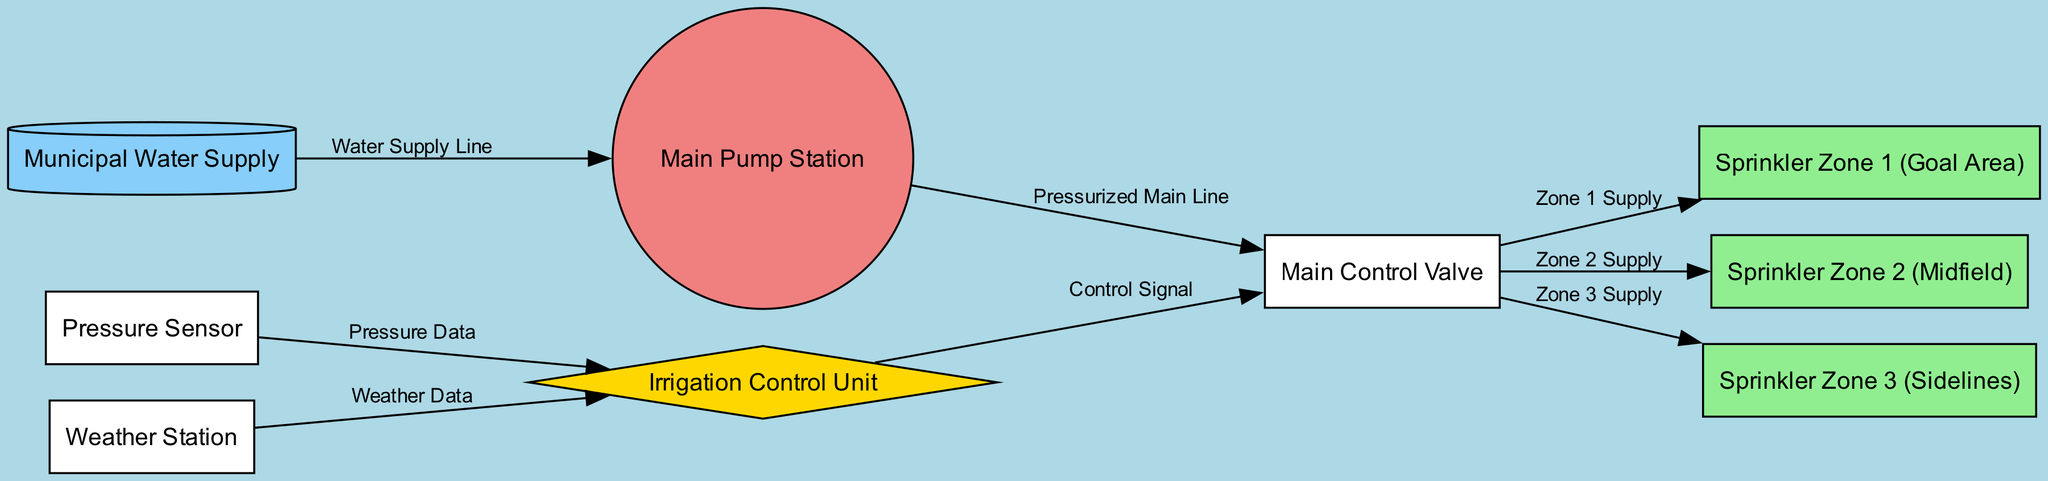What is the source of water for the irrigation system? The diagram specifies that the source of water is labeled as 'Municipal Water Supply.' It is represented as a node in the diagram.
Answer: Municipal Water Supply How many sprinkler zones are there in total? By counting the nodes connected to the main valve, there are three sprinkler zones indicated in the diagram: Zone 1, Zone 2, and Zone 3.
Answer: 3 What role does the irrigation control unit play? The irrigation control unit receives control signals from various nodes, including the weather station and pressure sensor, allowing it to manage the operation of the main control valve.
Answer: Manages irrigation What is the connection type between the main pump station and the main control valve? The edge connecting these two nodes is labeled 'Pressurized Main Line,' indicating the type of connection and flow direction between them in the system.
Answer: Pressurized Main Line Which sprinkler zone is located in the midfield area? The diagram explicitly labels 'Sprinkler Zone 2' as being located in the midfield area. This designation is indicated by the node label.
Answer: Sprinkler Zone 2 (Midfield) How does the control unit receive data about the pressure in the system? The control unit receives pressure data from the pressure sensor, as indicated by the directed edge labeled 'Pressure Data.' This signals communication between those two nodes.
Answer: Pressure Sensor What is the shape of the water source node? The diagram specifies that the water source node is shaped like a cylinder, visually indicating its type and function in the irrigation system.
Answer: Cylinder What is the purpose of the weather station in the irrigation system? The weather station provides weather data to the control unit, helping it make informed decisions about irrigation needs based on environmental conditions.
Answer: Provides weather data Which node directly influences the operation of the main control valve? The control unit sends a control signal to the main valve, directly influencing its operation in managing the flow of water to the sprinkler zones.
Answer: Control Unit 